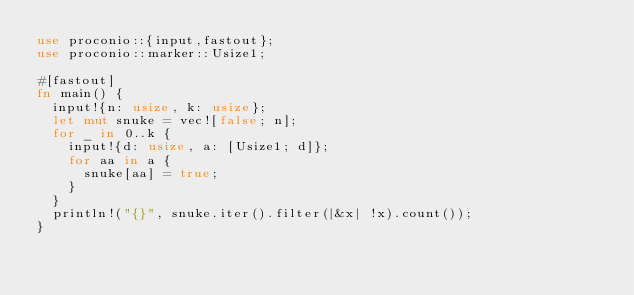<code> <loc_0><loc_0><loc_500><loc_500><_Rust_>use proconio::{input,fastout};
use proconio::marker::Usize1;

#[fastout]
fn main() {
  input!{n: usize, k: usize};
  let mut snuke = vec![false; n];
  for _ in 0..k {
    input!{d: usize, a: [Usize1; d]};
    for aa in a {
      snuke[aa] = true;
    }
  }
  println!("{}", snuke.iter().filter(|&x| !x).count());
}
</code> 